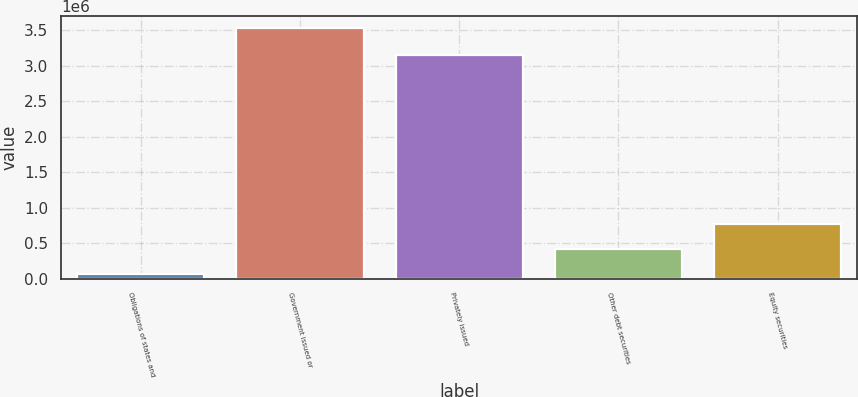Convert chart to OTSL. <chart><loc_0><loc_0><loc_500><loc_500><bar_chart><fcel>Obligations of states and<fcel>Government issued or<fcel>Privately issued<fcel>Other debt securities<fcel>Equity securities<nl><fcel>70425<fcel>3.5252e+06<fcel>3.15344e+06<fcel>415902<fcel>761379<nl></chart> 